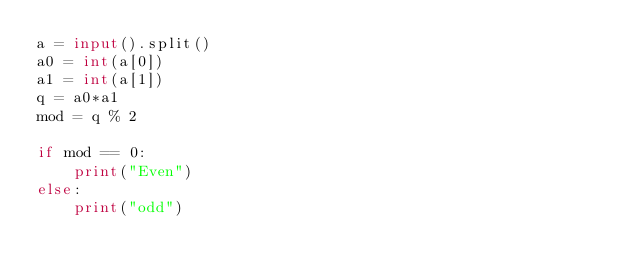Convert code to text. <code><loc_0><loc_0><loc_500><loc_500><_Python_>a = input().split()
a0 = int(a[0])
a1 = int(a[1])
q = a0*a1
mod = q % 2

if mod == 0:
	print("Even")
else:
	print("odd")</code> 